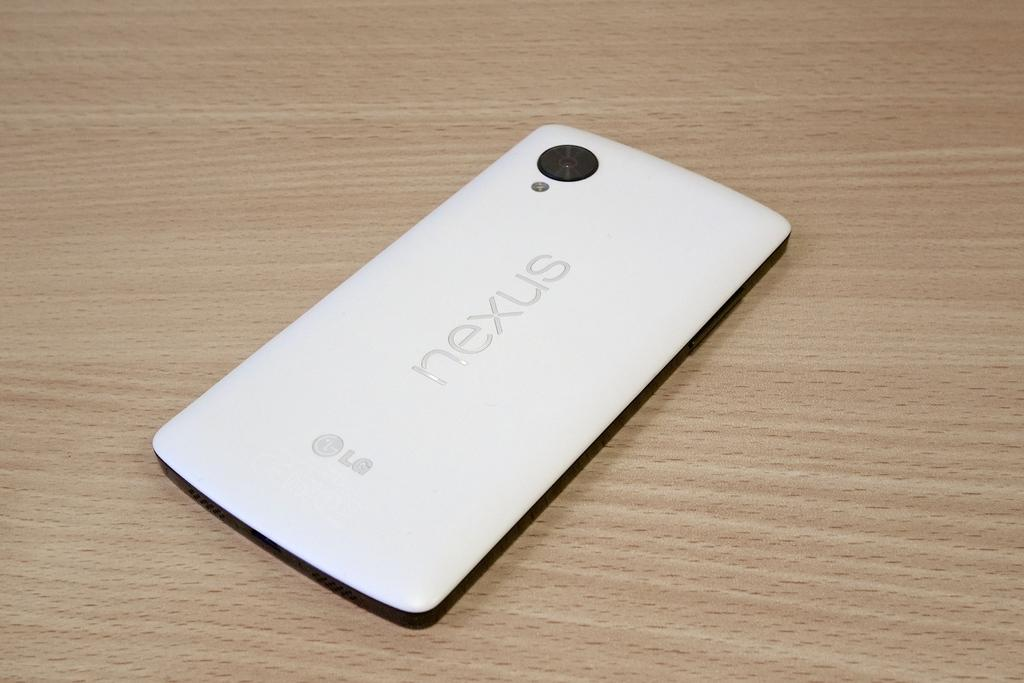Provide a one-sentence caption for the provided image. LG Nexus white cellphone laying face down on table. 